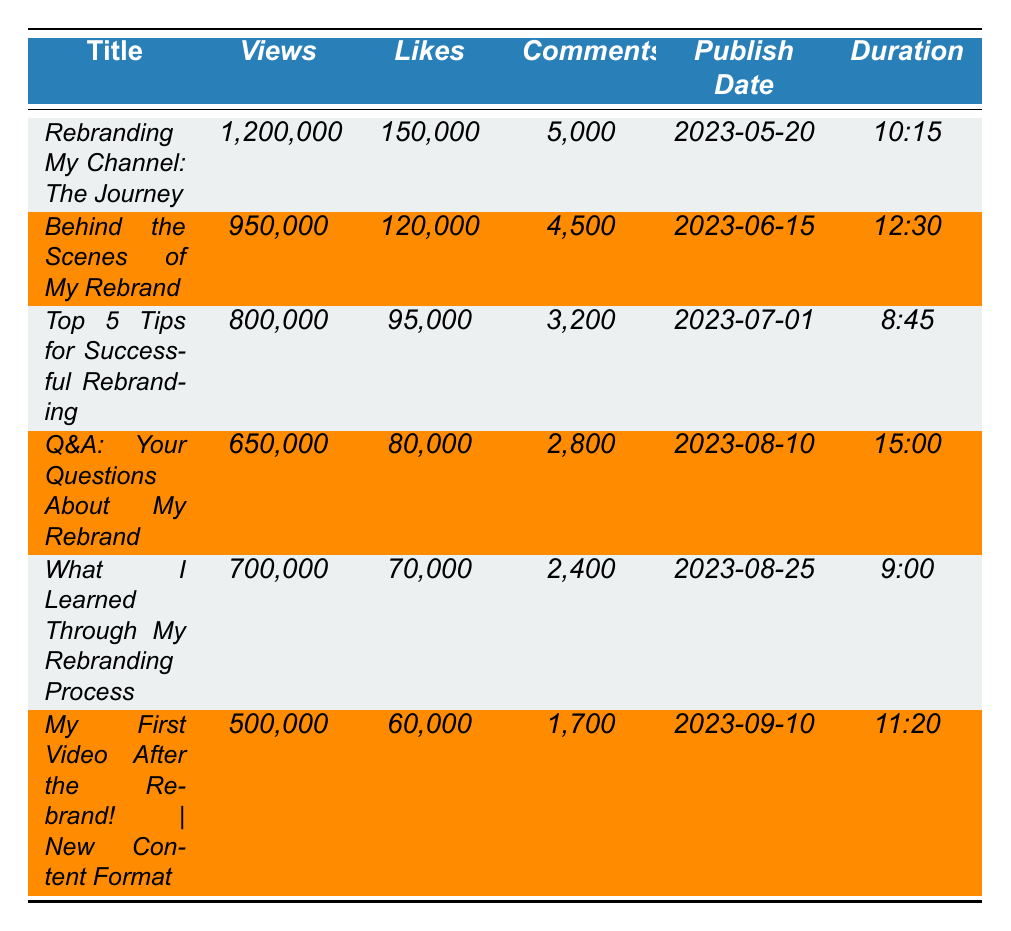What is the title of the top-performing video since the rebrand? The table lists the videos, and the first video has the highest views. That video is titled "Rebranding My Channel: The Journey."
Answer: Rebranding My Channel: The Journey How many views did "Top 5 Tips for Successful Rebranding" receive? By locating the title "Top 5 Tips for Successful Rebranding" in the table, the corresponding views are 800,000.
Answer: 800,000 Which video has the highest number of likes? The video "Rebranding My Channel: The Journey" has 150,000 likes, which is higher than any other video's likes listed.
Answer: Rebranding My Channel: The Journey What is the total number of likes for all videos listed? To find the total likes, sum up all the likes values from the table: 150,000 + 120,000 + 95,000 + 80,000 + 70,000 + 60,000 = 575,000.
Answer: 575,000 Which video was published the earliest? Checking the publish dates, "Rebranding My Channel: The Journey" was published on 2023-05-20, which is the earliest date compared to others.
Answer: Rebranding My Channel: The Journey Is there a video that received more than 1 million views? The table shows no video with more than 1,200,000 views, so there is no video that exceeds 1 million views.
Answer: No What is the average duration of the videos listed? The durations are: 10:15, 12:30, 8:45, 15:00, 9:00, and 11:20. Converting these to minutes gives: 10.25, 12.5, 8.75, 15.0, 9.0, 11.33. The average duration is (10.25 + 12.5 + 8.75 + 15.0 + 9.0 + 11.33)/6 = 11.12 minutes.
Answer: 11.12 minutes How many comments did the "Q&A: Your Questions About My Rebrand" video receive? Looking for the comments under "Q&A: Your Questions About My Rebrand," the table shows a total of 2,800 comments.
Answer: 2,800 What is the difference in views between the most viewed video and the least viewed video? The most viewed video has 1,200,000 views and the least viewed video has 500,000 views. The difference is 1,200,000 - 500,000 = 700,000 views.
Answer: 700,000 